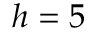Convert formula to latex. <formula><loc_0><loc_0><loc_500><loc_500>h = 5</formula> 